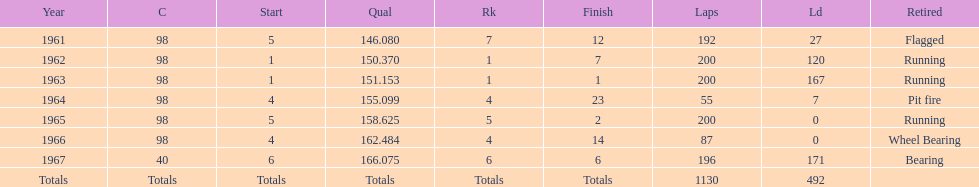What is the difference between the qualfying time in 1967 and 1965? 7.45. 